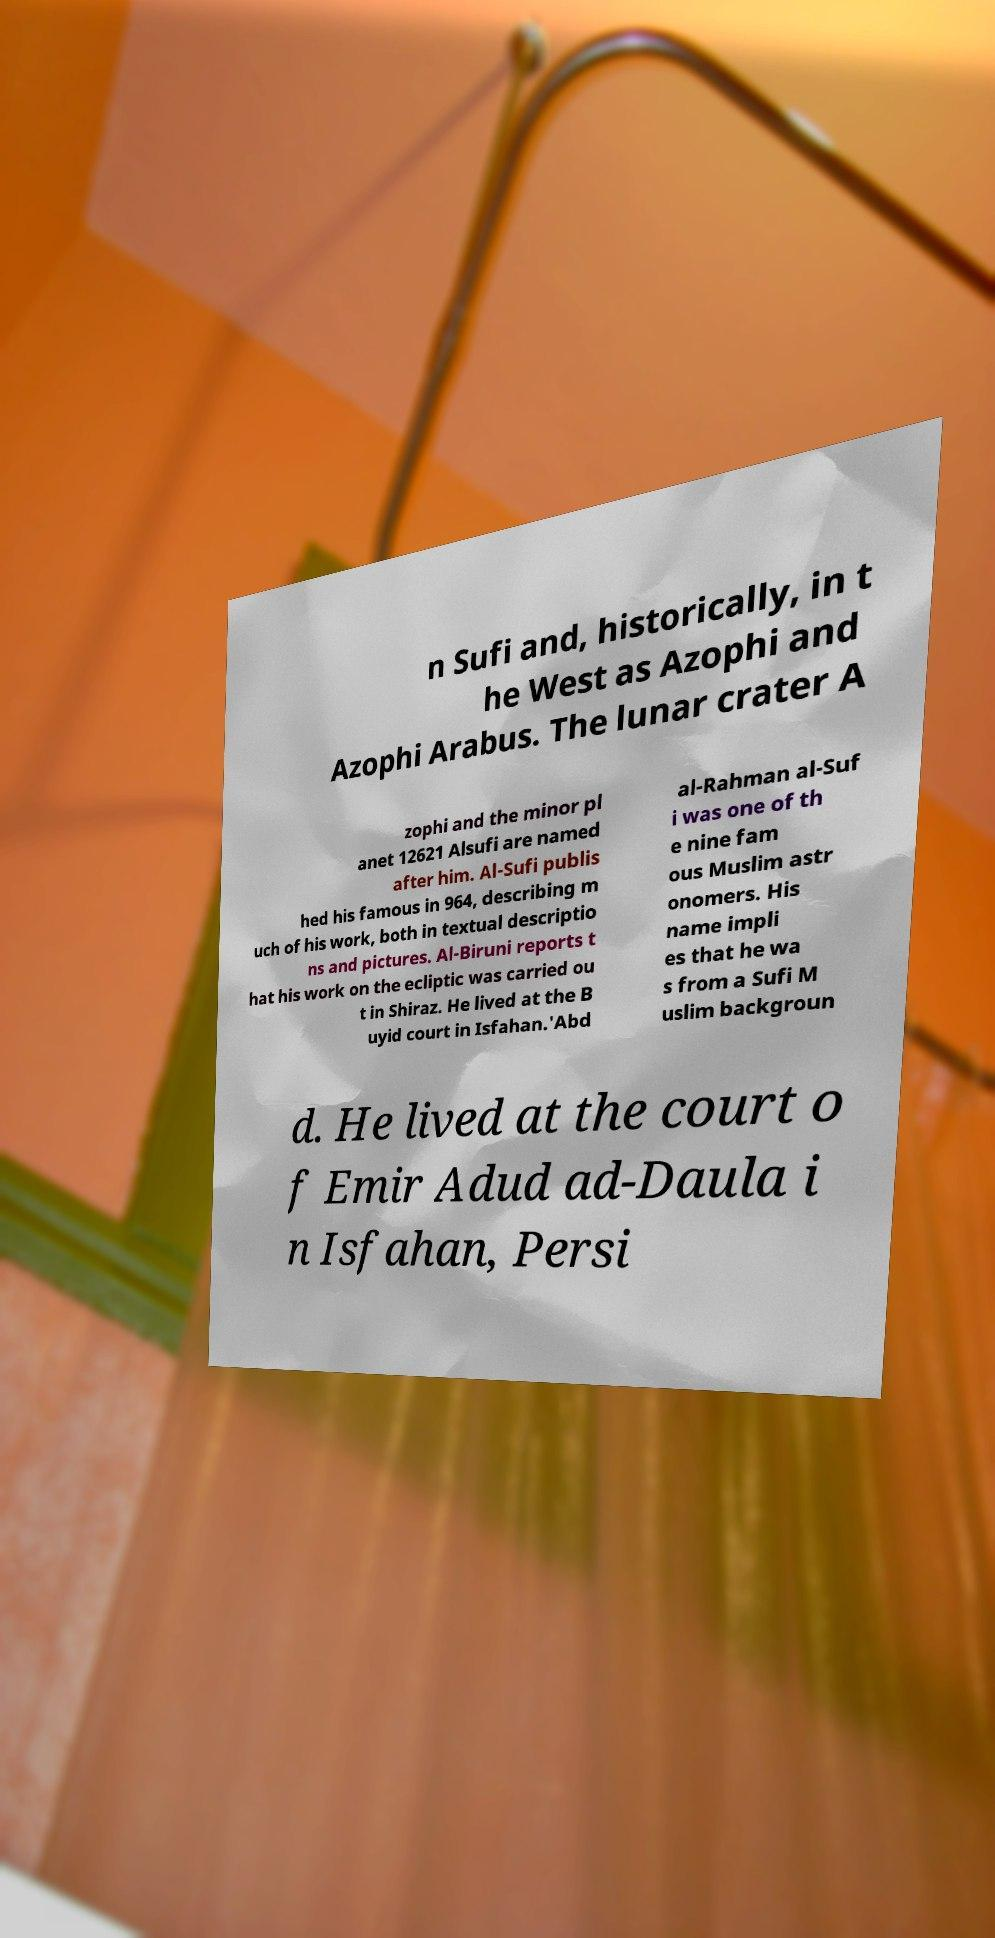Please identify and transcribe the text found in this image. n Sufi and, historically, in t he West as Azophi and Azophi Arabus. The lunar crater A zophi and the minor pl anet 12621 Alsufi are named after him. Al-Sufi publis hed his famous in 964, describing m uch of his work, both in textual descriptio ns and pictures. Al-Biruni reports t hat his work on the ecliptic was carried ou t in Shiraz. He lived at the B uyid court in Isfahan.'Abd al-Rahman al-Suf i was one of th e nine fam ous Muslim astr onomers. His name impli es that he wa s from a Sufi M uslim backgroun d. He lived at the court o f Emir Adud ad-Daula i n Isfahan, Persi 